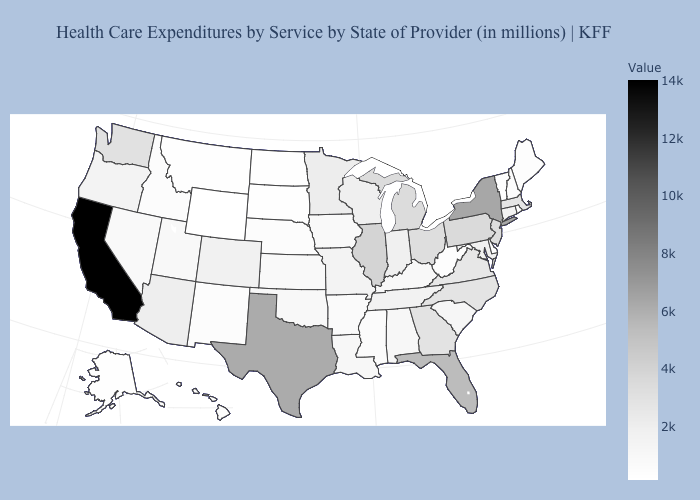Does Wyoming have the lowest value in the USA?
Keep it brief. Yes. Is the legend a continuous bar?
Concise answer only. Yes. Among the states that border Arkansas , which have the highest value?
Quick response, please. Texas. Among the states that border Maine , which have the lowest value?
Give a very brief answer. New Hampshire. Does California have the highest value in the USA?
Write a very short answer. Yes. Does South Carolina have the lowest value in the South?
Keep it brief. No. Which states have the lowest value in the USA?
Quick response, please. Wyoming. 